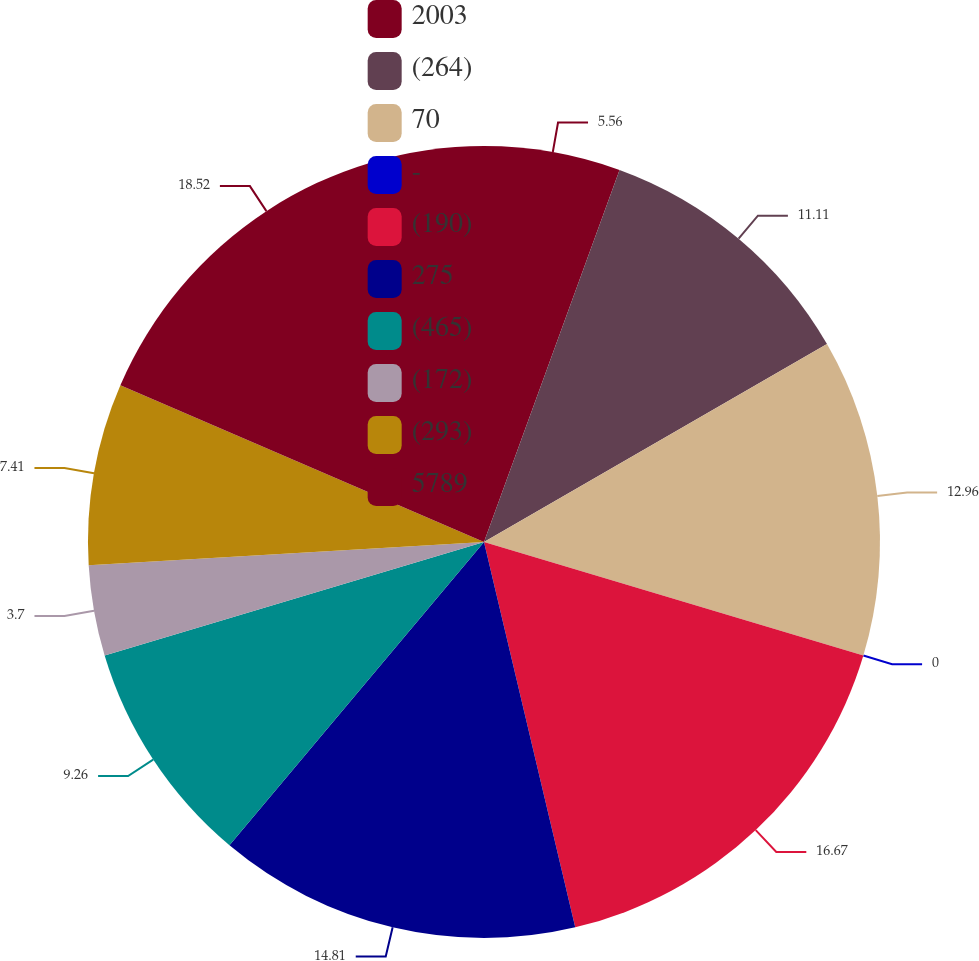Convert chart to OTSL. <chart><loc_0><loc_0><loc_500><loc_500><pie_chart><fcel>2003<fcel>(264)<fcel>70<fcel>-<fcel>(190)<fcel>275<fcel>(465)<fcel>(172)<fcel>(293)<fcel>5789<nl><fcel>5.56%<fcel>11.11%<fcel>12.96%<fcel>0.0%<fcel>16.67%<fcel>14.81%<fcel>9.26%<fcel>3.7%<fcel>7.41%<fcel>18.52%<nl></chart> 